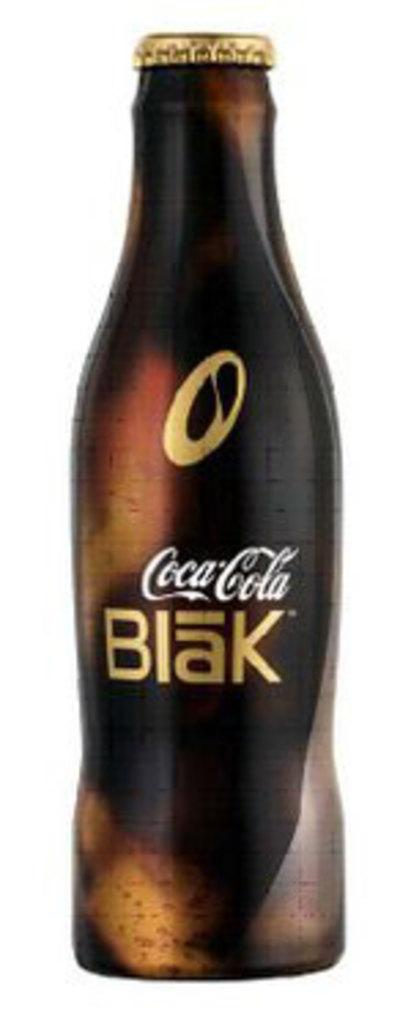<image>
Give a short and clear explanation of the subsequent image. Bottle with a gold cap inscribed with Coca-Cola BlaK 